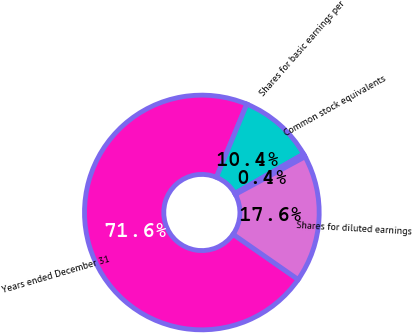<chart> <loc_0><loc_0><loc_500><loc_500><pie_chart><fcel>Years ended December 31<fcel>Shares for basic earnings per<fcel>Common stock equivalents<fcel>Shares for diluted earnings<nl><fcel>71.59%<fcel>10.44%<fcel>0.42%<fcel>17.56%<nl></chart> 